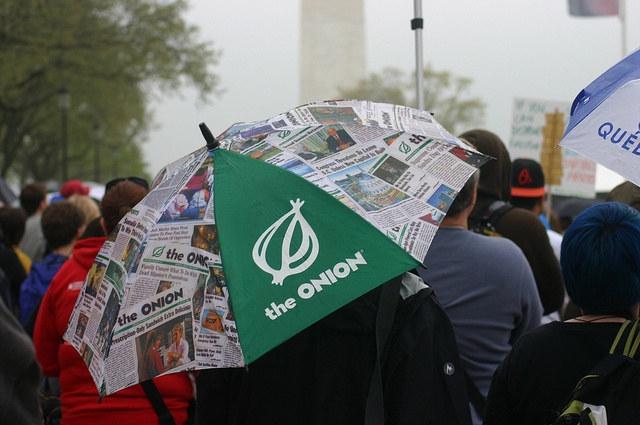Describe the objects in this image and their specific colors. I can see umbrella in darkgreen, teal, darkgray, gray, and lightgray tones, people in darkgreen, black, navy, and gray tones, backpack in black, gray, and darkgray tones, people in darkgreen, black, and gray tones, and people in black, maroon, and brown tones in this image. 